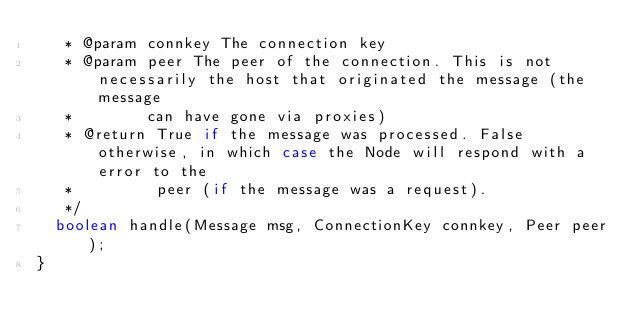<code> <loc_0><loc_0><loc_500><loc_500><_Java_>   * @param connkey The connection key
   * @param peer The peer of the connection. This is not necessarily the host that originated the message (the message
   *        can have gone via proxies)
   * @return True if the message was processed. False otherwise, in which case the Node will respond with a error to the
   *         peer (if the message was a request).
   */
  boolean handle(Message msg, ConnectionKey connkey, Peer peer);
}
</code> 